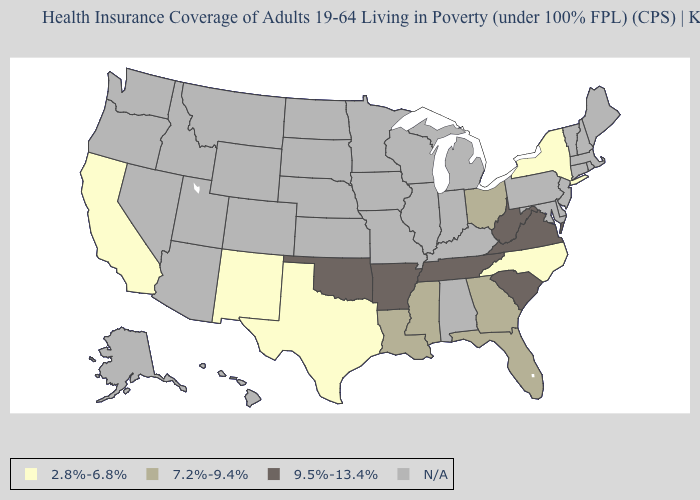What is the value of Massachusetts?
Short answer required. N/A. Does the map have missing data?
Answer briefly. Yes. Which states hav the highest value in the MidWest?
Concise answer only. Ohio. Name the states that have a value in the range 9.5%-13.4%?
Keep it brief. Arkansas, Oklahoma, South Carolina, Tennessee, Virginia, West Virginia. What is the value of Utah?
Quick response, please. N/A. What is the value of Vermont?
Answer briefly. N/A. What is the lowest value in the USA?
Write a very short answer. 2.8%-6.8%. Which states have the lowest value in the West?
Write a very short answer. California, New Mexico. What is the value of Florida?
Give a very brief answer. 7.2%-9.4%. Which states have the lowest value in the MidWest?
Quick response, please. Ohio. 